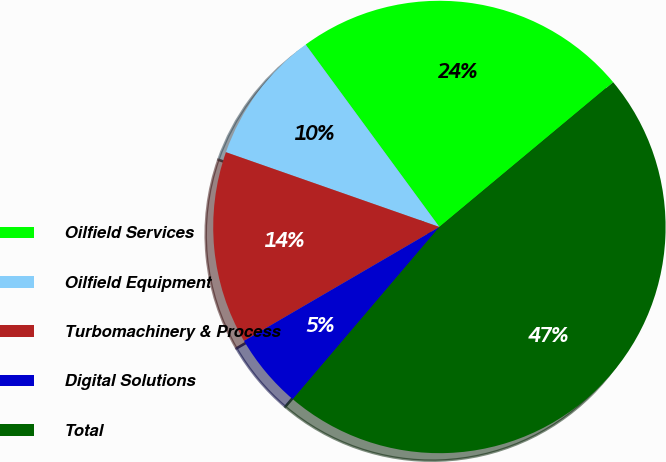Convert chart. <chart><loc_0><loc_0><loc_500><loc_500><pie_chart><fcel>Oilfield Services<fcel>Oilfield Equipment<fcel>Turbomachinery & Process<fcel>Digital Solutions<fcel>Total<nl><fcel>24.01%<fcel>9.57%<fcel>13.76%<fcel>5.38%<fcel>47.28%<nl></chart> 